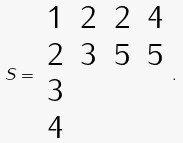Convert formula to latex. <formula><loc_0><loc_0><loc_500><loc_500>S = \begin{array} { c c c c } 1 & 2 & 2 & 4 \\ 2 & 3 & 5 & 5 \\ 3 & & & \\ 4 \end{array} .</formula> 